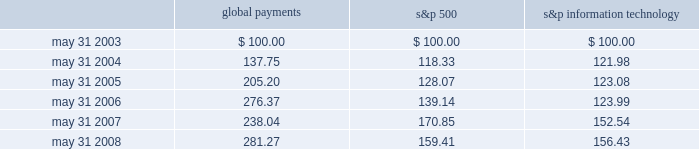Stock performance graph the following line-graph presentation compares our cumulative shareholder returns with the standard & poor 2019s information technology index and the standard & poor 2019s 500 stock index for the past five years .
The line graph assumes the investment of $ 100 in our common stock , the standard & poor 2019s information technology index , and the standard & poor 2019s 500 stock index on may 31 , 2003 and assumes reinvestment of all dividends .
Comparison of 5 year cumulative total return* among global payments inc. , the s&p 500 index and the s&p information technology index 5/03 5/04 5/05 5/06 5/07 5/08 global payments inc .
S&p 500 s&p information technology * $ 100 invested on 5/31/03 in stock or index-including reinvestment of dividends .
Fiscal year ending may 31 .
Global payments s&p 500 information technology .
Issuer purchases of equity securities in fiscal 2007 , our board of directors approved a share repurchase program that authorized the purchase of up to $ 100 million of global payments 2019 stock in the open market or as otherwise may be determined by us , subject to market conditions , business opportunities , and other factors .
Under this authorization , we have repurchased 2.3 million shares of our common stock .
This authorization has no expiration date and may be suspended or terminated at any time .
Repurchased shares will be retired but will be available for future issuance. .
What is the roi of global payments from 2003 to 2004? 
Computations: ((137.75 - 100) / 100)
Answer: 0.3775. 